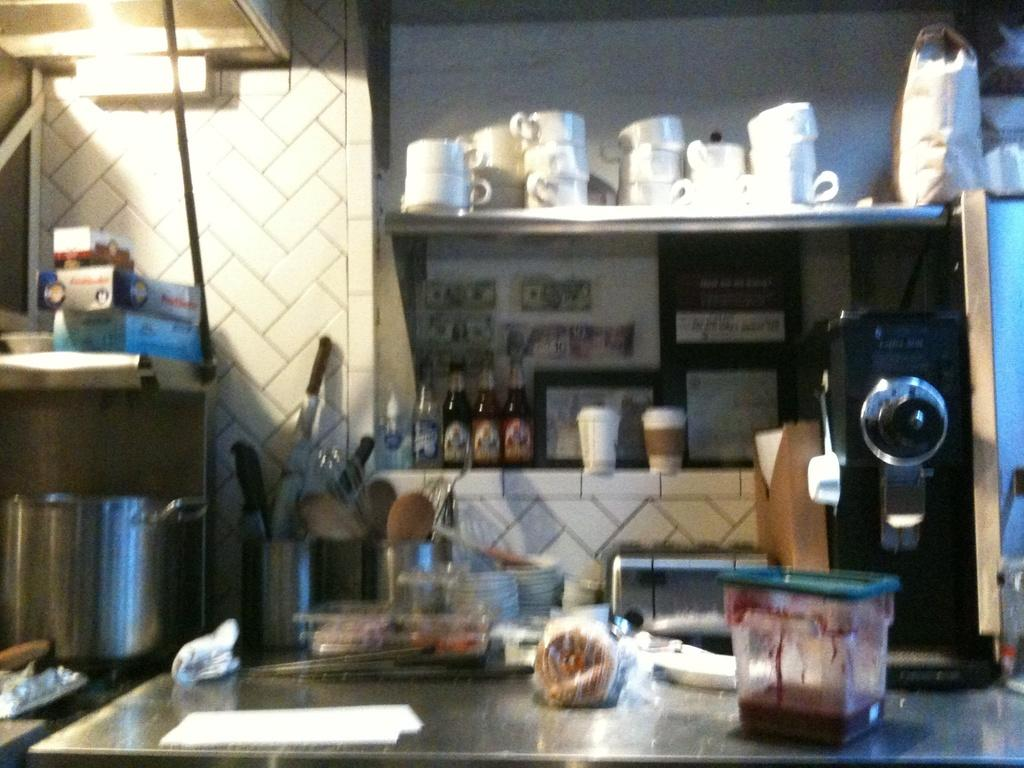What types of tableware can be seen in the image? There are plates, cups, and glasses in the image. What kitchen utensils are visible in the image? There are knives in a knife stand in the image. What type of container is present in the image? There is a box in the image. What beverage containers are in the image? There are bottles in the image. What type of bag is in the image? There is a bag in the image. What type of storage containers are in the image? There are cardboard boxes in the image. What other items can be seen on the table and racks in the image? There are other items on the table and racks in the image. What type of knee support is visible in the image? There is no knee support present in the image. What type of writing can be seen on the cardboard boxes in the image? There is no writing visible on the cardboard boxes in the image. 